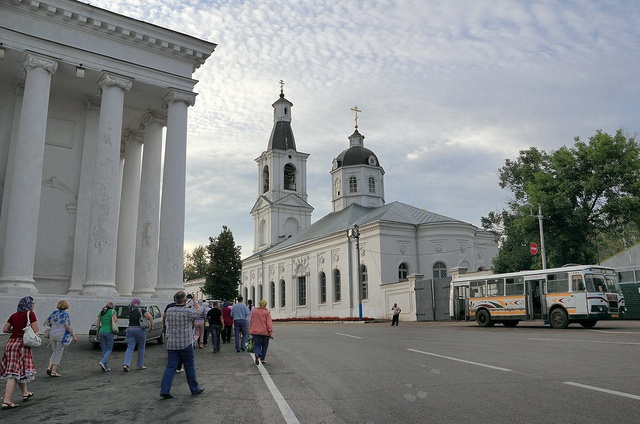Describe the objects in this image and their specific colors. I can see bus in black, gray, darkgray, and lightgray tones, people in black, gray, and navy tones, people in black, gray, and maroon tones, people in black, gray, and navy tones, and car in black and gray tones in this image. 